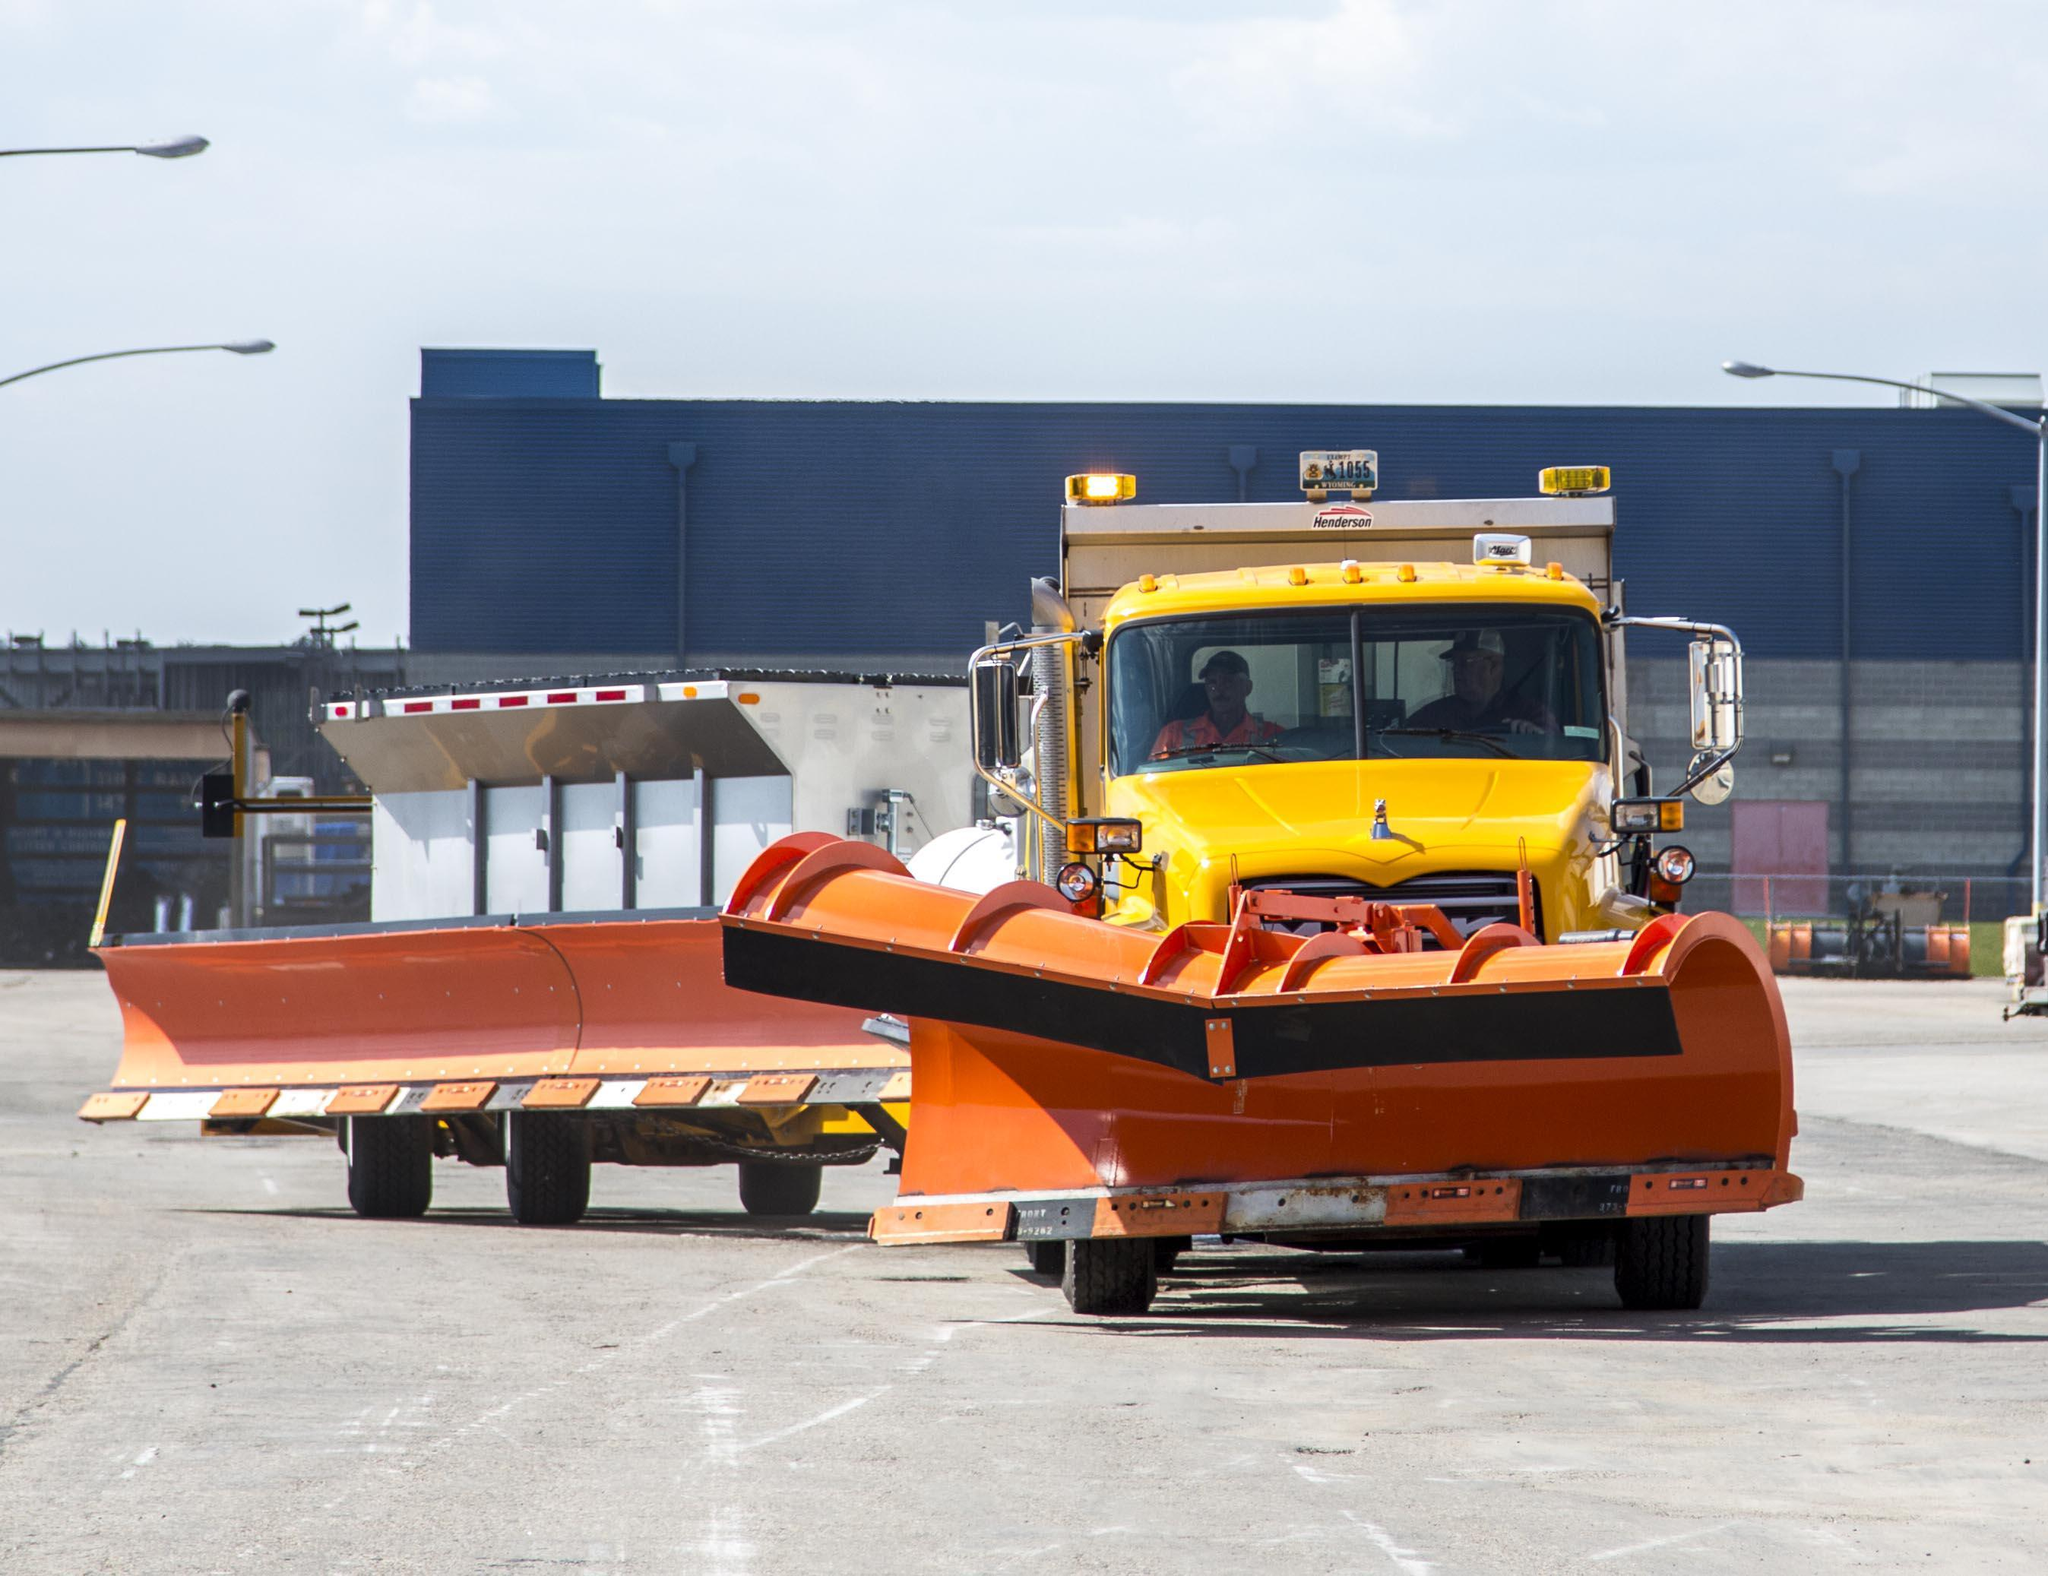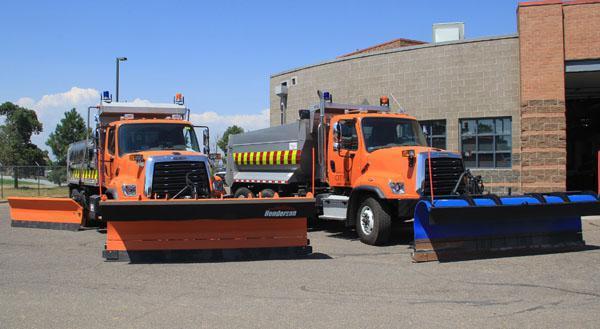The first image is the image on the left, the second image is the image on the right. Assess this claim about the two images: "The image on the left contains exactly one yellow truck". Correct or not? Answer yes or no. Yes. 